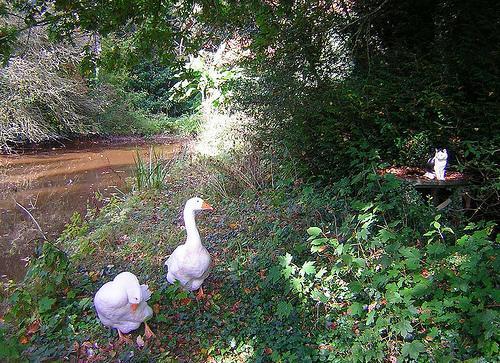How many ducks are in the photo?
Give a very brief answer. 2. 